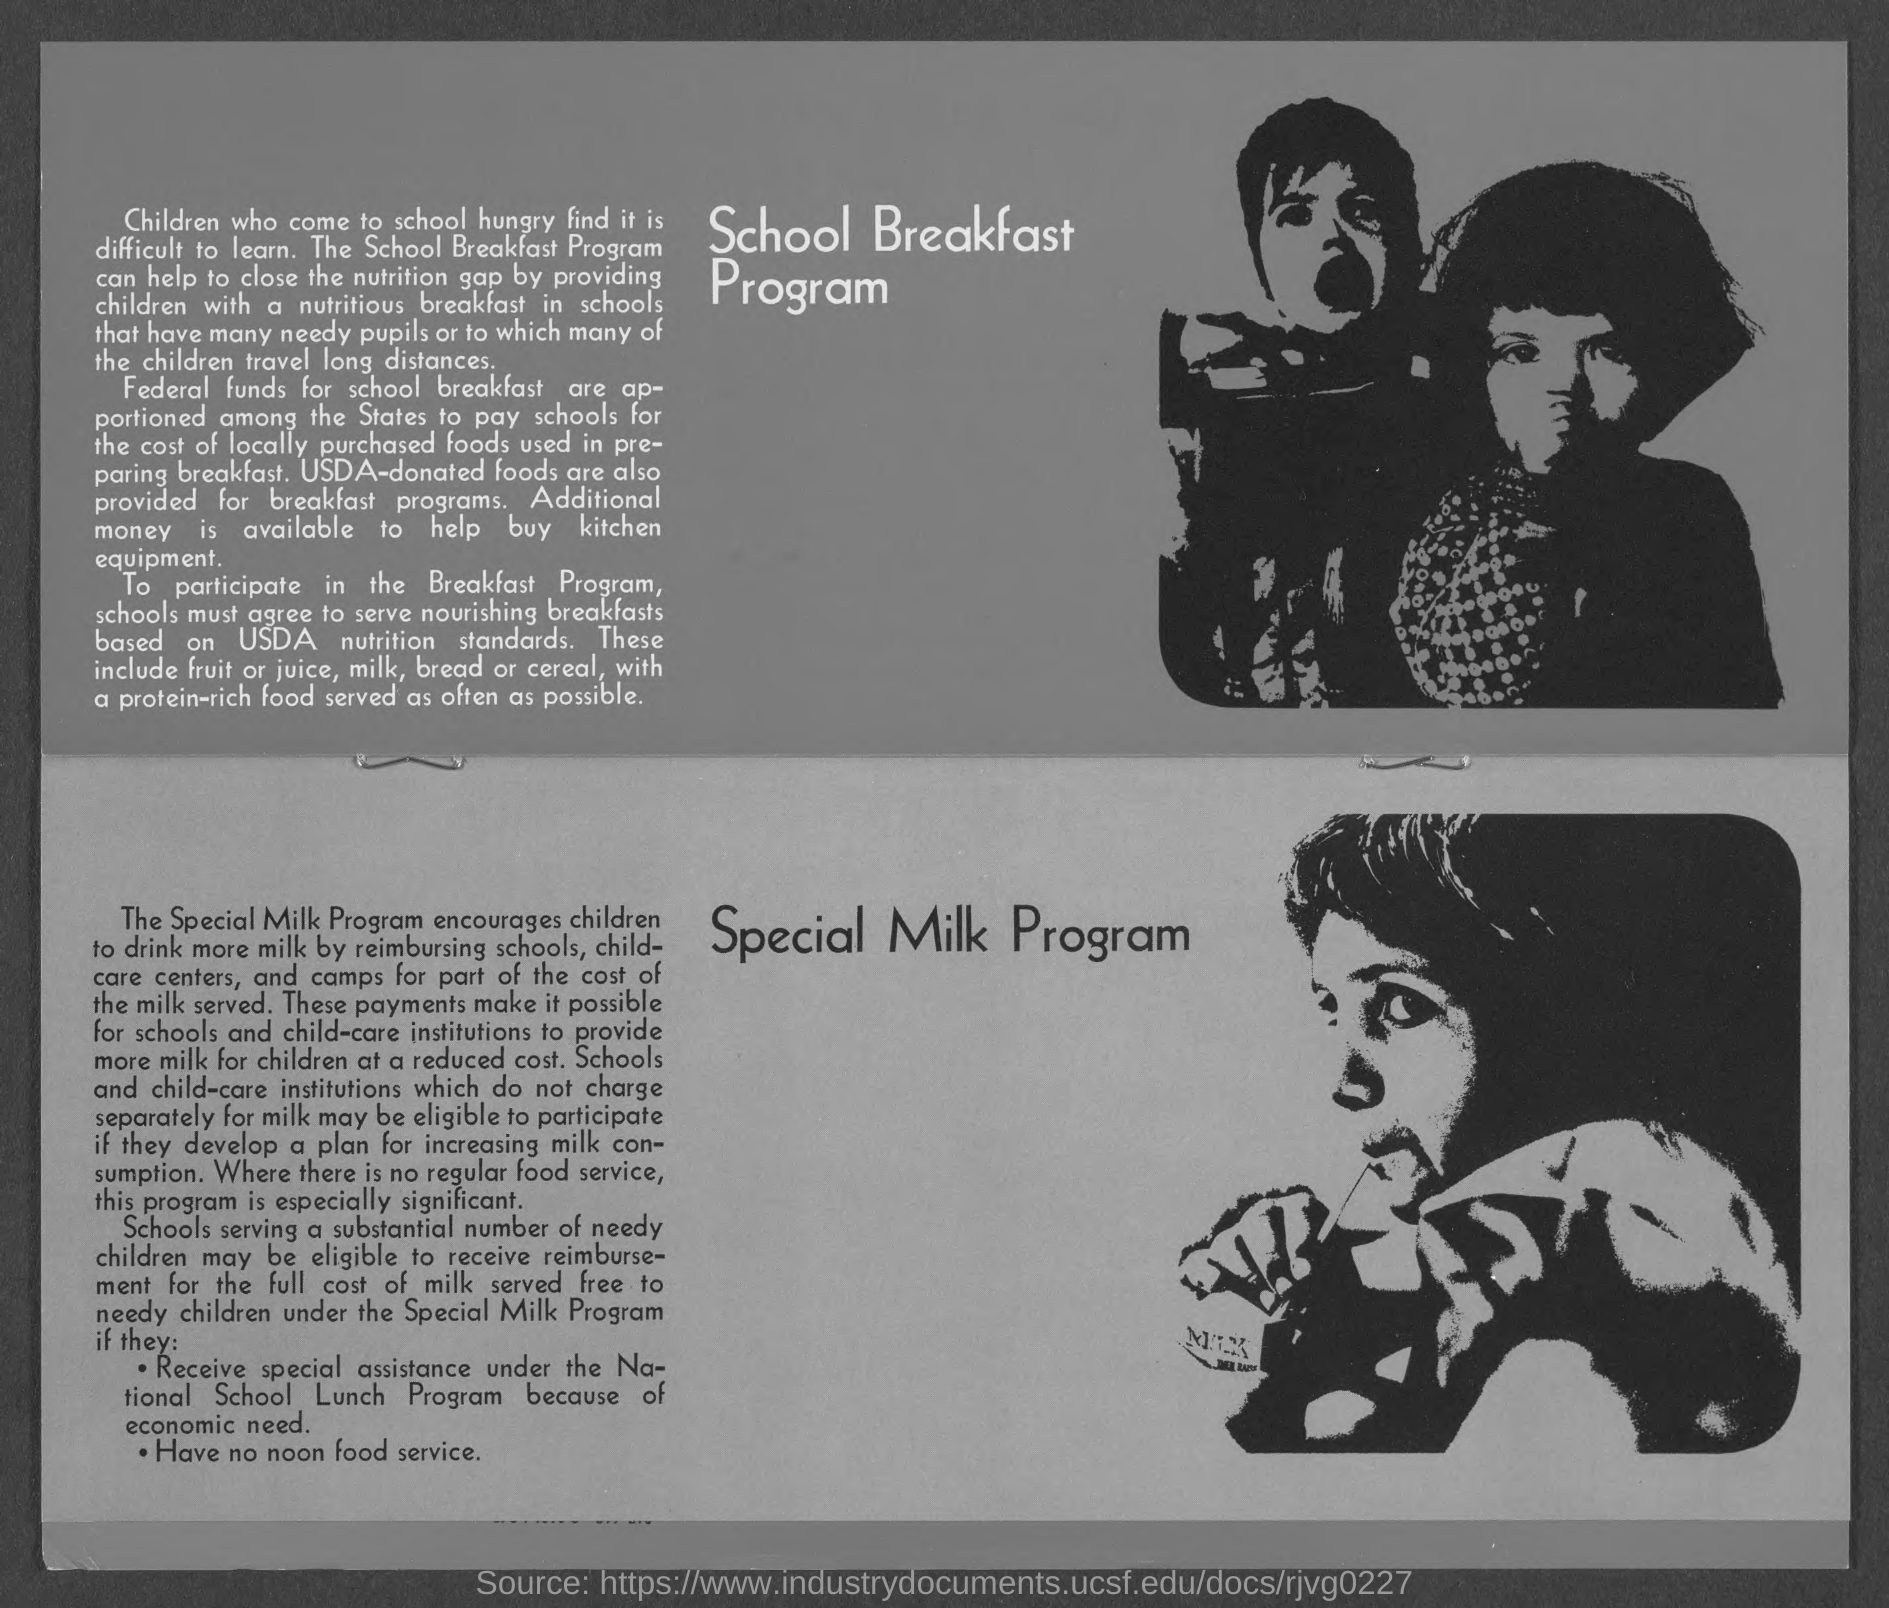Point out several critical features in this image. The heading of the top portion of the document is 'School Breakfast Program.' The document contains a heading in the bottom portion that reads "Special Milk Program. It is imperative that schools adhere to the United States Department of Agriculture (USDA) nutrition standards when serving breakfast to ensure that students are provided with nutritious and balanced meals. 